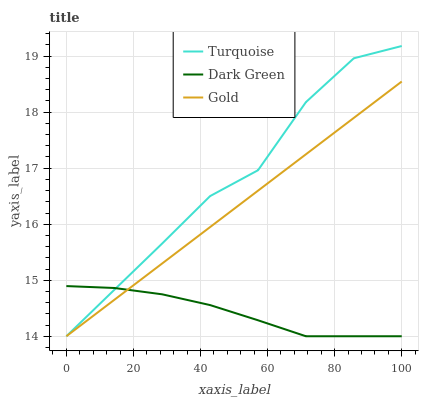Does Dark Green have the minimum area under the curve?
Answer yes or no. Yes. Does Turquoise have the maximum area under the curve?
Answer yes or no. Yes. Does Gold have the minimum area under the curve?
Answer yes or no. No. Does Gold have the maximum area under the curve?
Answer yes or no. No. Is Gold the smoothest?
Answer yes or no. Yes. Is Turquoise the roughest?
Answer yes or no. Yes. Is Dark Green the smoothest?
Answer yes or no. No. Is Dark Green the roughest?
Answer yes or no. No. Does Turquoise have the lowest value?
Answer yes or no. Yes. Does Turquoise have the highest value?
Answer yes or no. Yes. Does Gold have the highest value?
Answer yes or no. No. Does Turquoise intersect Dark Green?
Answer yes or no. Yes. Is Turquoise less than Dark Green?
Answer yes or no. No. Is Turquoise greater than Dark Green?
Answer yes or no. No. 